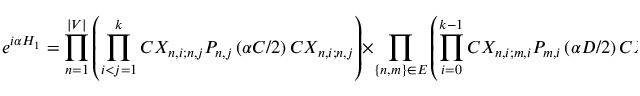Convert formula to latex. <formula><loc_0><loc_0><loc_500><loc_500>e ^ { i \alpha H _ { 1 } } = \prod _ { n = 1 } ^ { | V | } \left ( \prod _ { i < j = 1 } ^ { k } C X _ { n , i ; n , j } P _ { n , j } \left ( \alpha C / 2 \right ) C X _ { n , i ; n , j } \right ) \times \prod _ { \{ n , m \} \in E } \left ( \prod _ { i = 0 } ^ { k - 1 } C X _ { n , i ; m , i } P _ { m , i } \left ( \alpha D / 2 \right ) C X _ { n , i ; m , i } \right ) ,</formula> 